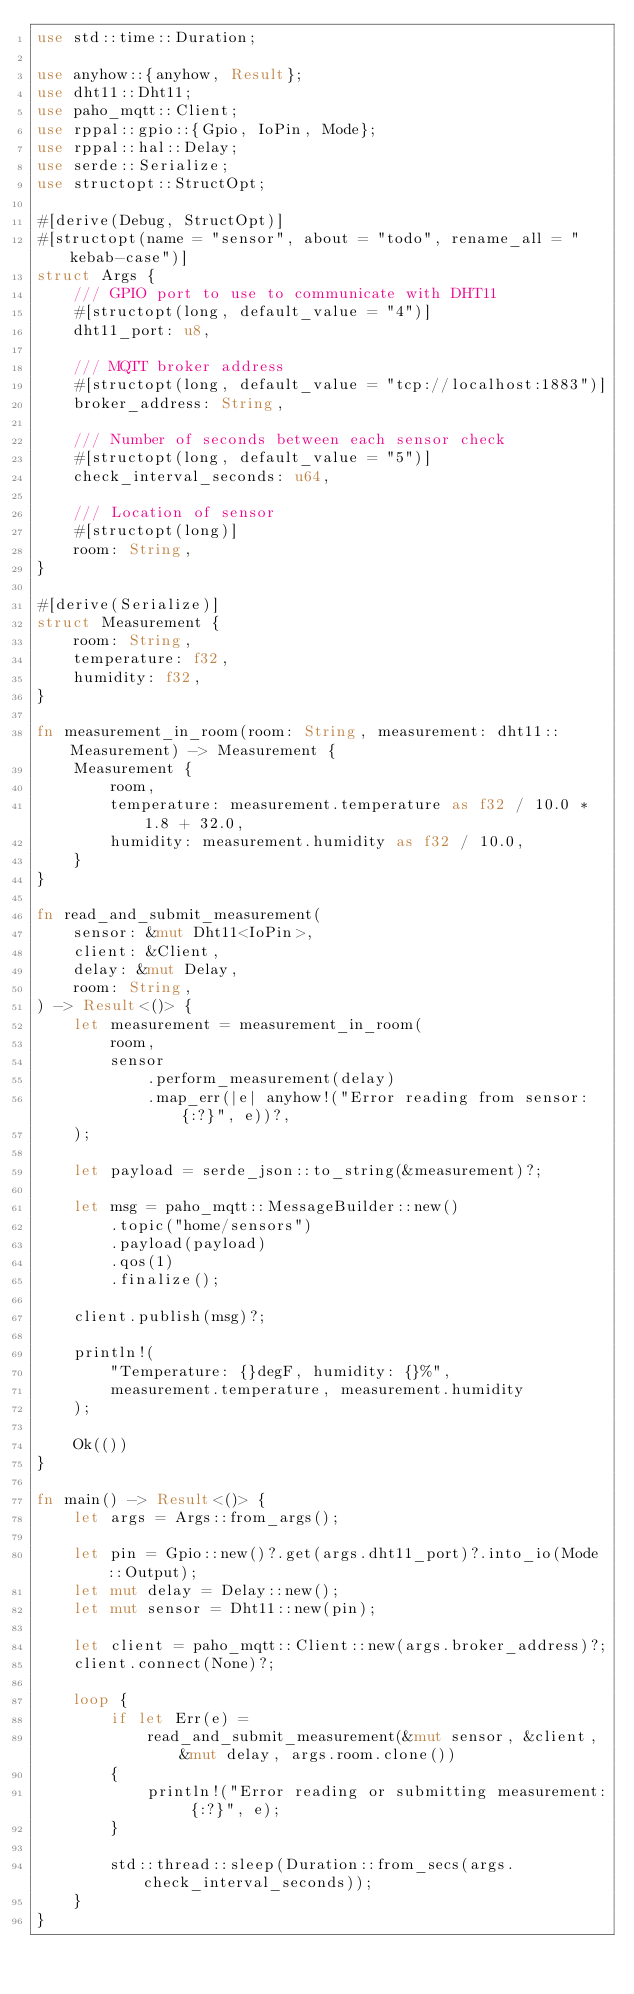Convert code to text. <code><loc_0><loc_0><loc_500><loc_500><_Rust_>use std::time::Duration;

use anyhow::{anyhow, Result};
use dht11::Dht11;
use paho_mqtt::Client;
use rppal::gpio::{Gpio, IoPin, Mode};
use rppal::hal::Delay;
use serde::Serialize;
use structopt::StructOpt;

#[derive(Debug, StructOpt)]
#[structopt(name = "sensor", about = "todo", rename_all = "kebab-case")]
struct Args {
    /// GPIO port to use to communicate with DHT11
    #[structopt(long, default_value = "4")]
    dht11_port: u8,

    /// MQTT broker address
    #[structopt(long, default_value = "tcp://localhost:1883")]
    broker_address: String,

    /// Number of seconds between each sensor check
    #[structopt(long, default_value = "5")]
    check_interval_seconds: u64,

    /// Location of sensor
    #[structopt(long)]
    room: String,
}

#[derive(Serialize)]
struct Measurement {
    room: String,
    temperature: f32,
    humidity: f32,
}

fn measurement_in_room(room: String, measurement: dht11::Measurement) -> Measurement {
    Measurement {
        room,
        temperature: measurement.temperature as f32 / 10.0 * 1.8 + 32.0,
        humidity: measurement.humidity as f32 / 10.0,
    }
}

fn read_and_submit_measurement(
    sensor: &mut Dht11<IoPin>,
    client: &Client,
    delay: &mut Delay,
    room: String,
) -> Result<()> {
    let measurement = measurement_in_room(
        room,
        sensor
            .perform_measurement(delay)
            .map_err(|e| anyhow!("Error reading from sensor: {:?}", e))?,
    );

    let payload = serde_json::to_string(&measurement)?;

    let msg = paho_mqtt::MessageBuilder::new()
        .topic("home/sensors")
        .payload(payload)
        .qos(1)
        .finalize();

    client.publish(msg)?;

    println!(
        "Temperature: {}degF, humidity: {}%",
        measurement.temperature, measurement.humidity
    );

    Ok(())
}

fn main() -> Result<()> {
    let args = Args::from_args();

    let pin = Gpio::new()?.get(args.dht11_port)?.into_io(Mode::Output);
    let mut delay = Delay::new();
    let mut sensor = Dht11::new(pin);

    let client = paho_mqtt::Client::new(args.broker_address)?;
    client.connect(None)?;

    loop {
        if let Err(e) =
            read_and_submit_measurement(&mut sensor, &client, &mut delay, args.room.clone())
        {
            println!("Error reading or submitting measurement: {:?}", e);
        }

        std::thread::sleep(Duration::from_secs(args.check_interval_seconds));
    }
}
</code> 